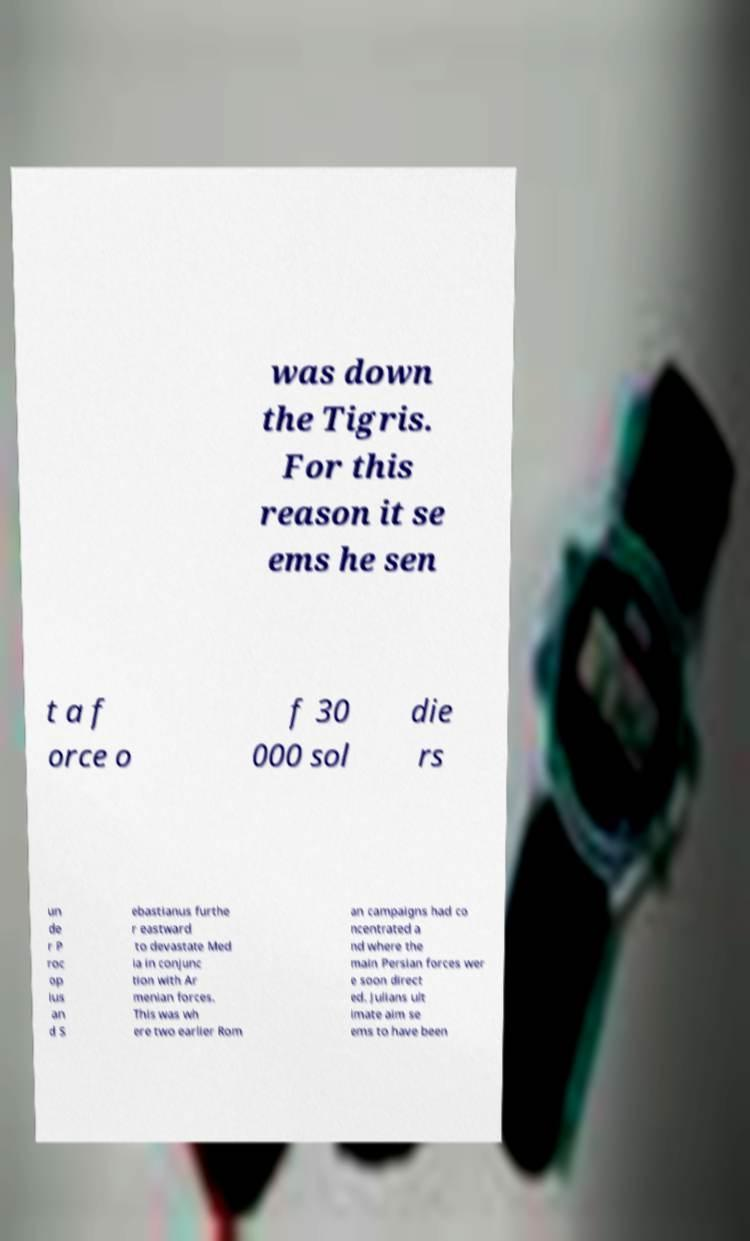Could you assist in decoding the text presented in this image and type it out clearly? was down the Tigris. For this reason it se ems he sen t a f orce o f 30 000 sol die rs un de r P roc op ius an d S ebastianus furthe r eastward to devastate Med ia in conjunc tion with Ar menian forces. This was wh ere two earlier Rom an campaigns had co ncentrated a nd where the main Persian forces wer e soon direct ed. Julians ult imate aim se ems to have been 